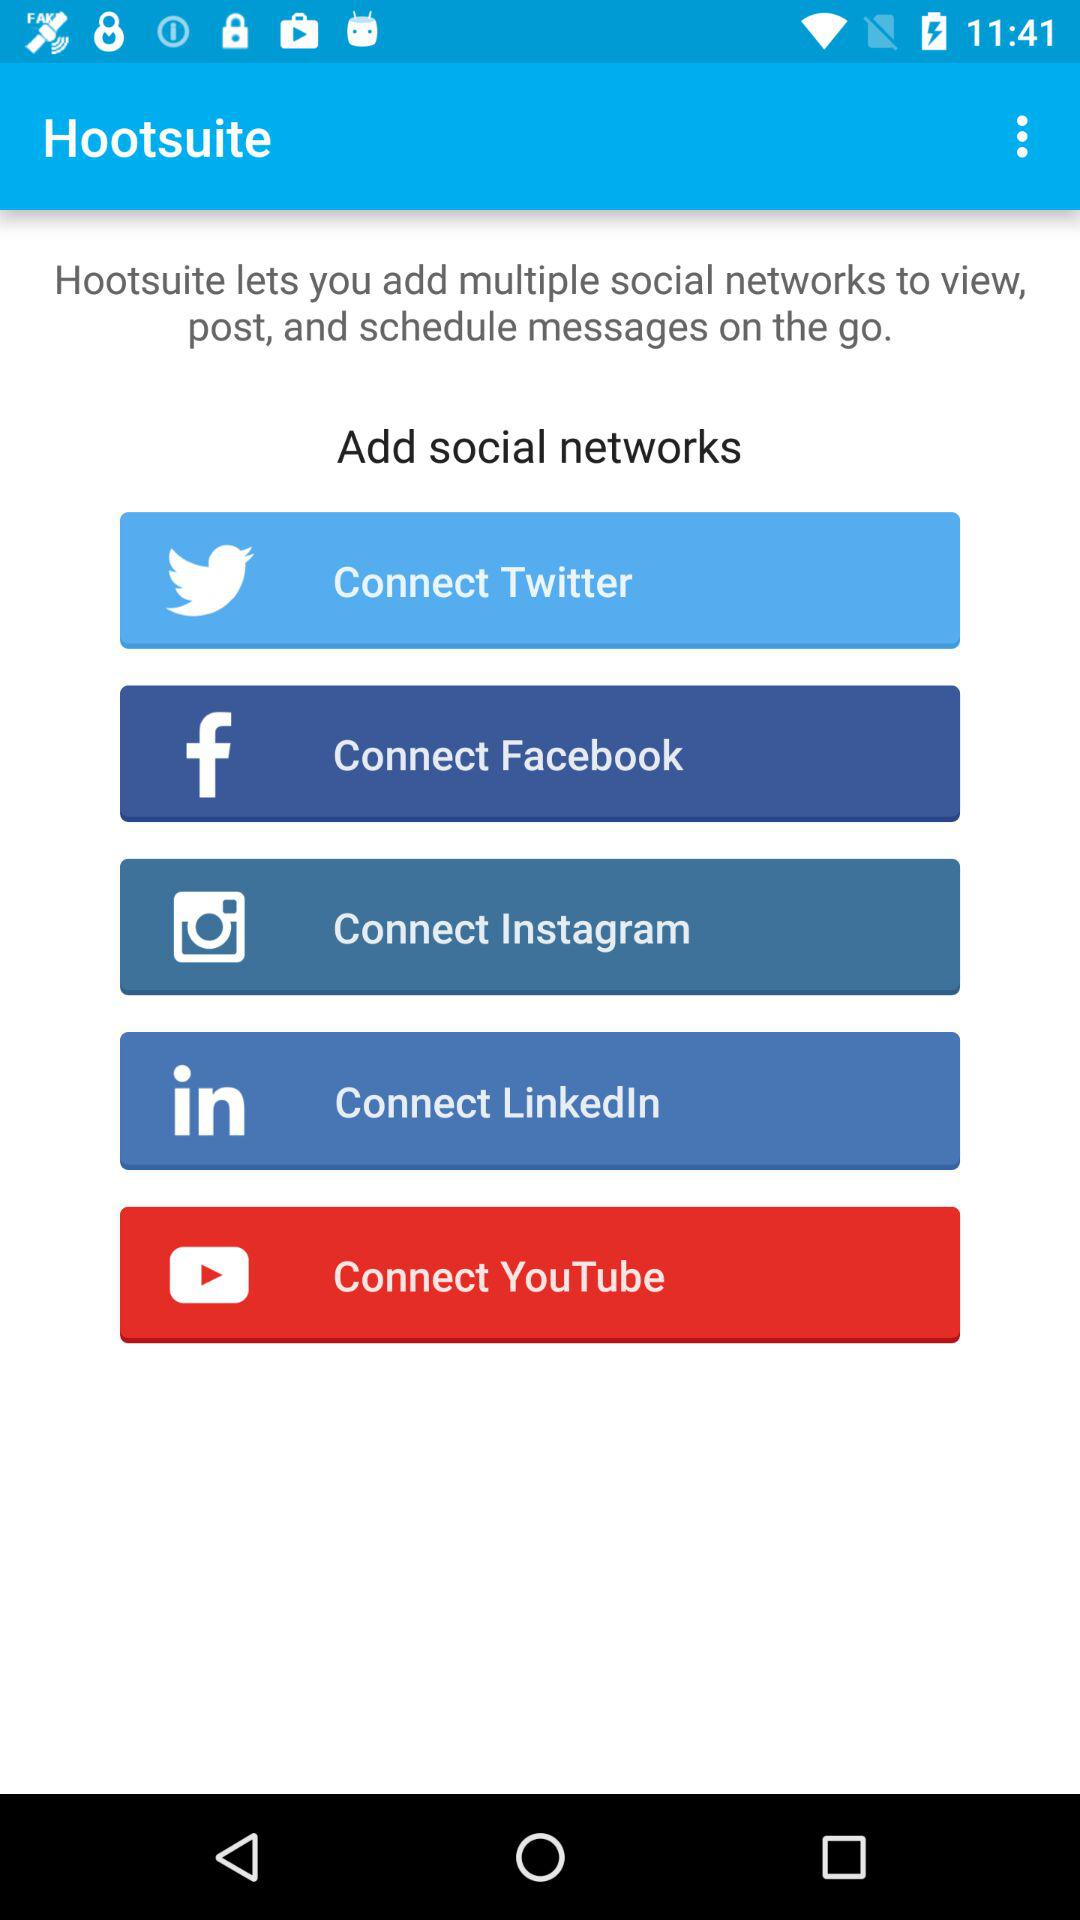How many social networks can you connect to Hootsuite?
Answer the question using a single word or phrase. 5 